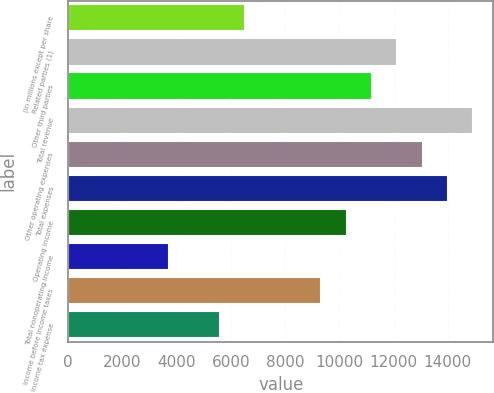Convert chart. <chart><loc_0><loc_0><loc_500><loc_500><bar_chart><fcel>(in millions except per share<fcel>Related parties (1)<fcel>Other third parties<fcel>Total revenue<fcel>Other operating expenses<fcel>Total expenses<fcel>Operating income<fcel>Total nonoperating income<fcel>Income before income taxes<fcel>Income tax expense<nl><fcel>6537.7<fcel>12136.3<fcel>11203.2<fcel>14935.6<fcel>13069.4<fcel>14002.5<fcel>10270.1<fcel>3738.4<fcel>9337<fcel>5604.6<nl></chart> 